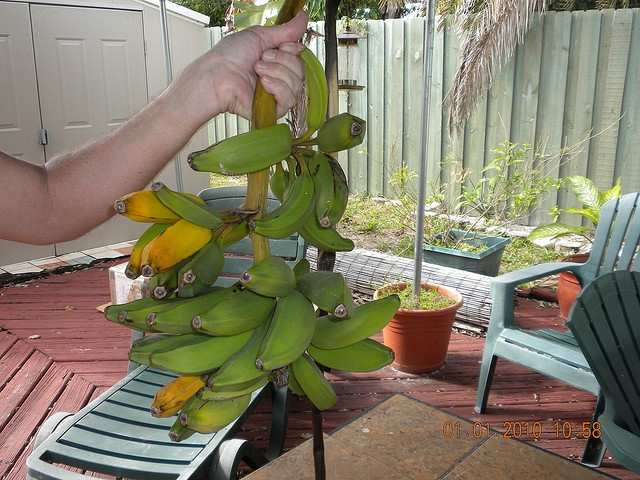Describe the objects in this image and their specific colors. I can see banana in black, darkgreen, gray, and olive tones, people in black, gray, darkgray, and brown tones, chair in black, darkgray, gray, and lightgray tones, chair in black, darkgray, gray, and lightblue tones, and potted plant in black, darkgray, gray, olive, and khaki tones in this image. 